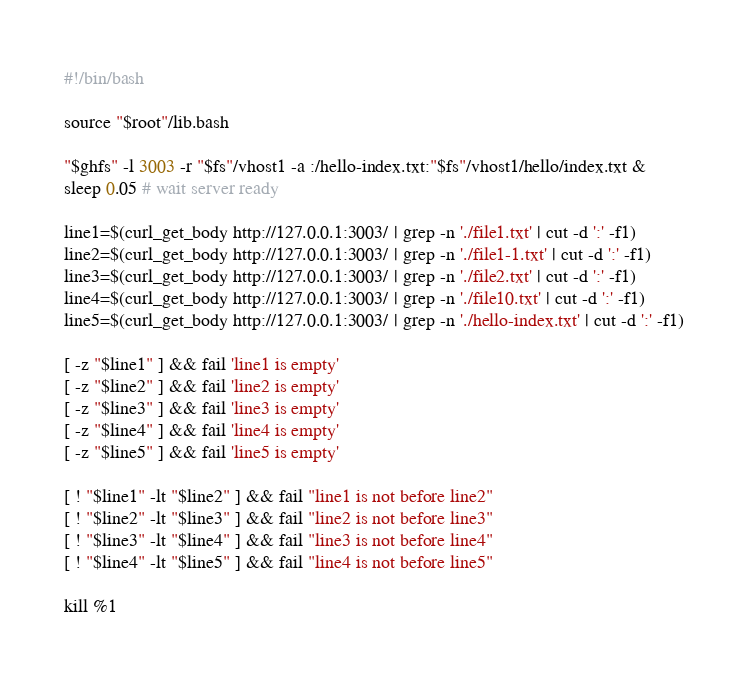Convert code to text. <code><loc_0><loc_0><loc_500><loc_500><_Bash_>#!/bin/bash

source "$root"/lib.bash

"$ghfs" -l 3003 -r "$fs"/vhost1 -a :/hello-index.txt:"$fs"/vhost1/hello/index.txt &
sleep 0.05 # wait server ready

line1=$(curl_get_body http://127.0.0.1:3003/ | grep -n './file1.txt' | cut -d ':' -f1)
line2=$(curl_get_body http://127.0.0.1:3003/ | grep -n './file1-1.txt' | cut -d ':' -f1)
line3=$(curl_get_body http://127.0.0.1:3003/ | grep -n './file2.txt' | cut -d ':' -f1)
line4=$(curl_get_body http://127.0.0.1:3003/ | grep -n './file10.txt' | cut -d ':' -f1)
line5=$(curl_get_body http://127.0.0.1:3003/ | grep -n './hello-index.txt' | cut -d ':' -f1)

[ -z "$line1" ] && fail 'line1 is empty'
[ -z "$line2" ] && fail 'line2 is empty'
[ -z "$line3" ] && fail 'line3 is empty'
[ -z "$line4" ] && fail 'line4 is empty'
[ -z "$line5" ] && fail 'line5 is empty'

[ ! "$line1" -lt "$line2" ] && fail "line1 is not before line2"
[ ! "$line2" -lt "$line3" ] && fail "line2 is not before line3"
[ ! "$line3" -lt "$line4" ] && fail "line3 is not before line4"
[ ! "$line4" -lt "$line5" ] && fail "line4 is not before line5"

kill %1
</code> 